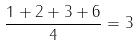Convert formula to latex. <formula><loc_0><loc_0><loc_500><loc_500>\frac { 1 + 2 + 3 + 6 } { 4 } = 3</formula> 